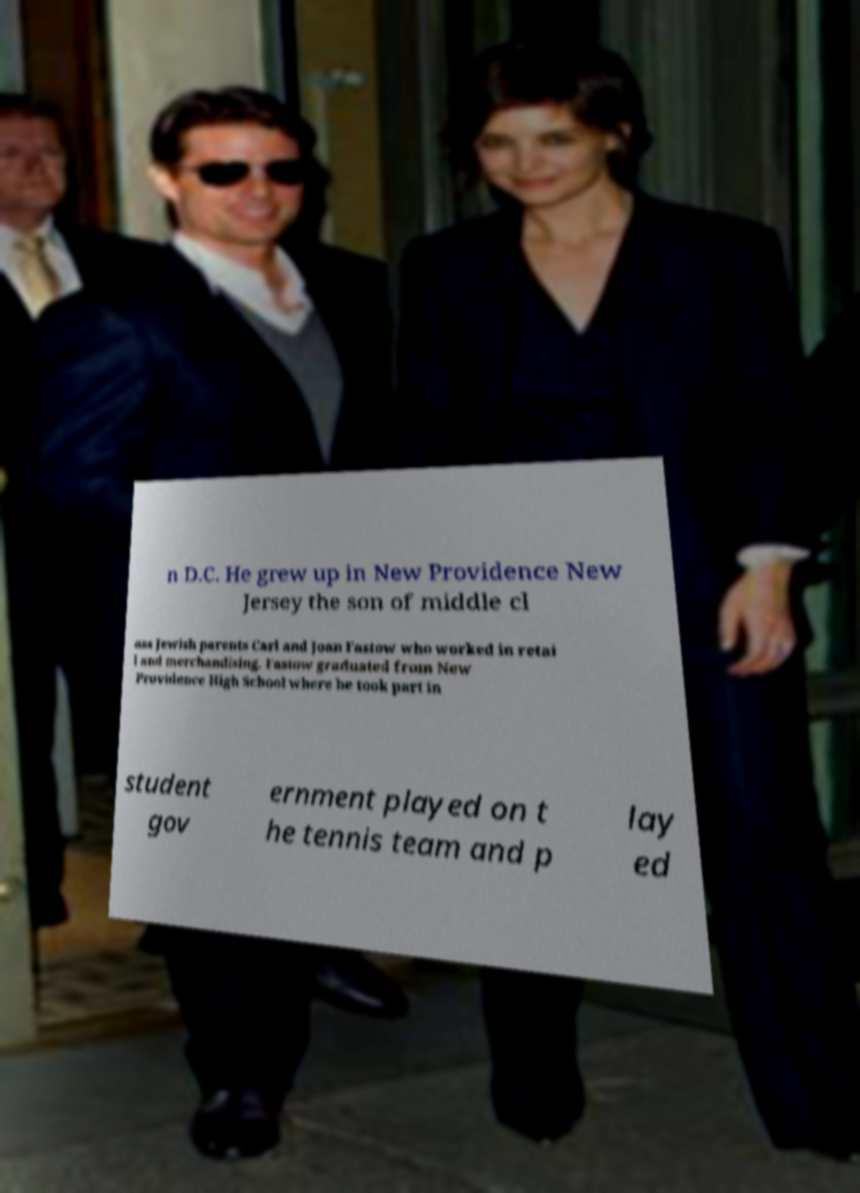There's text embedded in this image that I need extracted. Can you transcribe it verbatim? n D.C. He grew up in New Providence New Jersey the son of middle cl ass Jewish parents Carl and Joan Fastow who worked in retai l and merchandising. Fastow graduated from New Providence High School where he took part in student gov ernment played on t he tennis team and p lay ed 